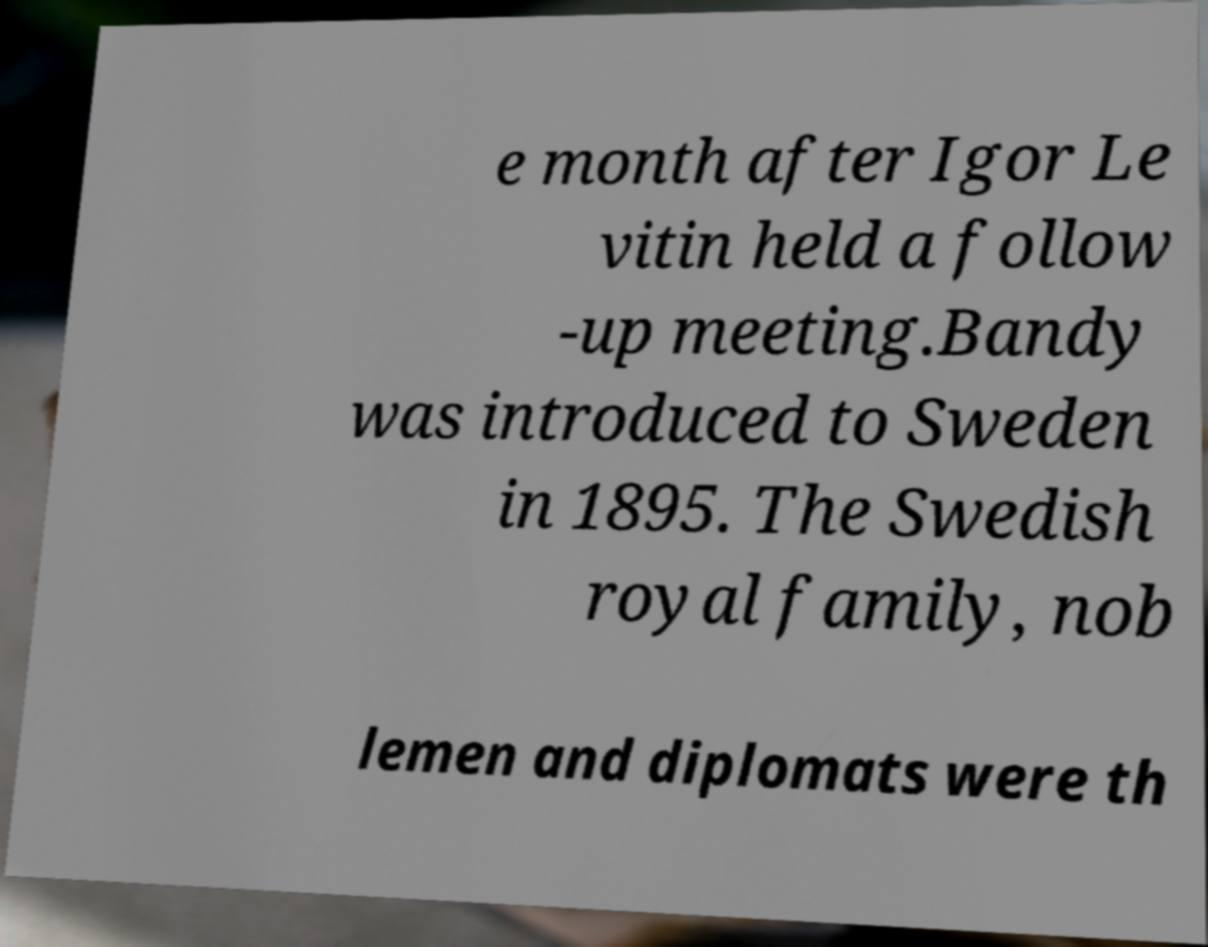I need the written content from this picture converted into text. Can you do that? e month after Igor Le vitin held a follow -up meeting.Bandy was introduced to Sweden in 1895. The Swedish royal family, nob lemen and diplomats were th 